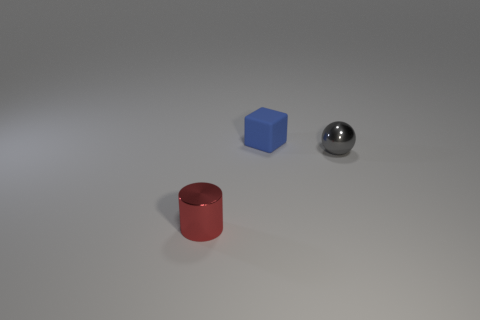Add 1 small yellow things. How many objects exist? 4 Subtract all spheres. How many objects are left? 2 Subtract 1 blue blocks. How many objects are left? 2 Subtract all yellow metal blocks. Subtract all tiny blocks. How many objects are left? 2 Add 2 tiny red objects. How many tiny red objects are left? 3 Add 3 tiny red cubes. How many tiny red cubes exist? 3 